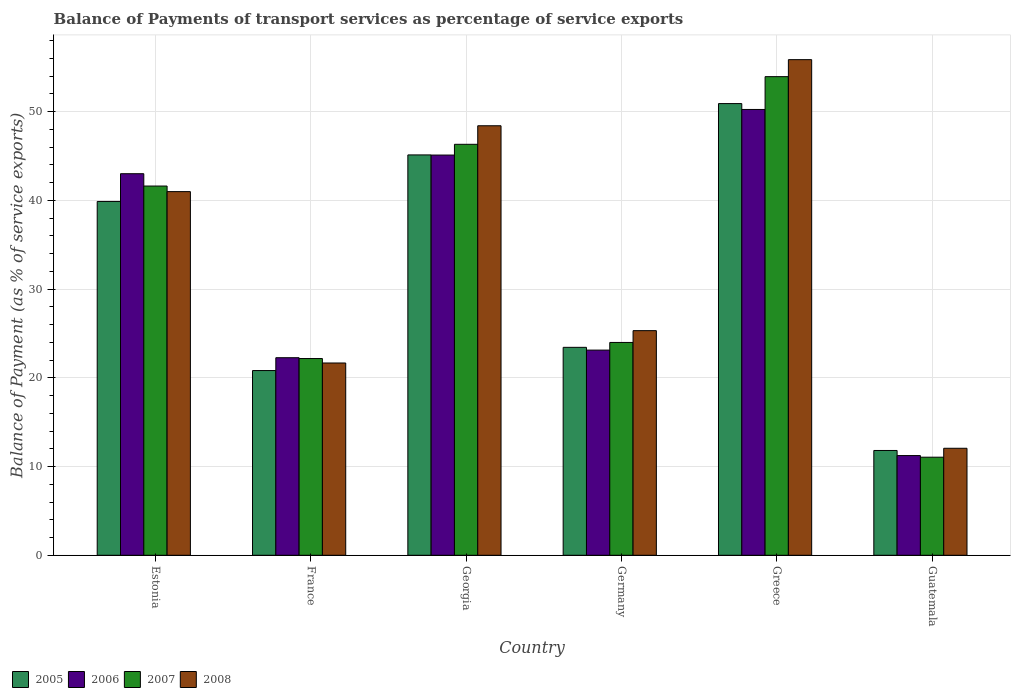How many different coloured bars are there?
Your answer should be very brief. 4. How many bars are there on the 1st tick from the right?
Make the answer very short. 4. What is the label of the 2nd group of bars from the left?
Offer a terse response. France. What is the balance of payments of transport services in 2007 in Greece?
Keep it short and to the point. 53.95. Across all countries, what is the maximum balance of payments of transport services in 2007?
Your answer should be very brief. 53.95. Across all countries, what is the minimum balance of payments of transport services in 2008?
Offer a very short reply. 12.06. In which country was the balance of payments of transport services in 2007 minimum?
Ensure brevity in your answer.  Guatemala. What is the total balance of payments of transport services in 2006 in the graph?
Your answer should be very brief. 195.02. What is the difference between the balance of payments of transport services in 2006 in Estonia and that in Greece?
Make the answer very short. -7.24. What is the difference between the balance of payments of transport services in 2008 in Estonia and the balance of payments of transport services in 2005 in Guatemala?
Keep it short and to the point. 29.18. What is the average balance of payments of transport services in 2008 per country?
Make the answer very short. 34.06. What is the difference between the balance of payments of transport services of/in 2006 and balance of payments of transport services of/in 2005 in Germany?
Ensure brevity in your answer.  -0.31. What is the ratio of the balance of payments of transport services in 2006 in Greece to that in Guatemala?
Offer a very short reply. 4.47. What is the difference between the highest and the second highest balance of payments of transport services in 2008?
Provide a short and direct response. 7.42. What is the difference between the highest and the lowest balance of payments of transport services in 2007?
Offer a very short reply. 42.9. Is the sum of the balance of payments of transport services in 2005 in Estonia and Greece greater than the maximum balance of payments of transport services in 2008 across all countries?
Keep it short and to the point. Yes. What does the 2nd bar from the right in France represents?
Make the answer very short. 2007. How many countries are there in the graph?
Your answer should be very brief. 6. How many legend labels are there?
Give a very brief answer. 4. What is the title of the graph?
Provide a short and direct response. Balance of Payments of transport services as percentage of service exports. Does "1979" appear as one of the legend labels in the graph?
Keep it short and to the point. No. What is the label or title of the Y-axis?
Give a very brief answer. Balance of Payment (as % of service exports). What is the Balance of Payment (as % of service exports) of 2005 in Estonia?
Provide a short and direct response. 39.88. What is the Balance of Payment (as % of service exports) in 2006 in Estonia?
Your answer should be compact. 43.01. What is the Balance of Payment (as % of service exports) of 2007 in Estonia?
Ensure brevity in your answer.  41.62. What is the Balance of Payment (as % of service exports) in 2008 in Estonia?
Make the answer very short. 40.99. What is the Balance of Payment (as % of service exports) of 2005 in France?
Your answer should be very brief. 20.82. What is the Balance of Payment (as % of service exports) of 2006 in France?
Offer a terse response. 22.27. What is the Balance of Payment (as % of service exports) in 2007 in France?
Provide a succinct answer. 22.18. What is the Balance of Payment (as % of service exports) of 2008 in France?
Provide a short and direct response. 21.67. What is the Balance of Payment (as % of service exports) of 2005 in Georgia?
Your response must be concise. 45.13. What is the Balance of Payment (as % of service exports) of 2006 in Georgia?
Your answer should be compact. 45.11. What is the Balance of Payment (as % of service exports) in 2007 in Georgia?
Provide a short and direct response. 46.33. What is the Balance of Payment (as % of service exports) of 2008 in Georgia?
Your answer should be compact. 48.42. What is the Balance of Payment (as % of service exports) in 2005 in Germany?
Offer a very short reply. 23.44. What is the Balance of Payment (as % of service exports) in 2006 in Germany?
Ensure brevity in your answer.  23.13. What is the Balance of Payment (as % of service exports) in 2007 in Germany?
Provide a succinct answer. 23.99. What is the Balance of Payment (as % of service exports) in 2008 in Germany?
Provide a succinct answer. 25.32. What is the Balance of Payment (as % of service exports) in 2005 in Greece?
Provide a short and direct response. 50.92. What is the Balance of Payment (as % of service exports) of 2006 in Greece?
Offer a terse response. 50.25. What is the Balance of Payment (as % of service exports) in 2007 in Greece?
Your answer should be compact. 53.95. What is the Balance of Payment (as % of service exports) in 2008 in Greece?
Provide a short and direct response. 55.87. What is the Balance of Payment (as % of service exports) in 2005 in Guatemala?
Offer a terse response. 11.81. What is the Balance of Payment (as % of service exports) of 2006 in Guatemala?
Provide a succinct answer. 11.24. What is the Balance of Payment (as % of service exports) in 2007 in Guatemala?
Keep it short and to the point. 11.06. What is the Balance of Payment (as % of service exports) of 2008 in Guatemala?
Offer a terse response. 12.06. Across all countries, what is the maximum Balance of Payment (as % of service exports) of 2005?
Your answer should be compact. 50.92. Across all countries, what is the maximum Balance of Payment (as % of service exports) in 2006?
Offer a terse response. 50.25. Across all countries, what is the maximum Balance of Payment (as % of service exports) of 2007?
Provide a succinct answer. 53.95. Across all countries, what is the maximum Balance of Payment (as % of service exports) of 2008?
Provide a succinct answer. 55.87. Across all countries, what is the minimum Balance of Payment (as % of service exports) of 2005?
Your response must be concise. 11.81. Across all countries, what is the minimum Balance of Payment (as % of service exports) of 2006?
Keep it short and to the point. 11.24. Across all countries, what is the minimum Balance of Payment (as % of service exports) of 2007?
Your answer should be compact. 11.06. Across all countries, what is the minimum Balance of Payment (as % of service exports) in 2008?
Ensure brevity in your answer.  12.06. What is the total Balance of Payment (as % of service exports) of 2005 in the graph?
Offer a very short reply. 192.01. What is the total Balance of Payment (as % of service exports) in 2006 in the graph?
Provide a short and direct response. 195.02. What is the total Balance of Payment (as % of service exports) of 2007 in the graph?
Your response must be concise. 199.12. What is the total Balance of Payment (as % of service exports) of 2008 in the graph?
Make the answer very short. 204.34. What is the difference between the Balance of Payment (as % of service exports) of 2005 in Estonia and that in France?
Make the answer very short. 19.06. What is the difference between the Balance of Payment (as % of service exports) in 2006 in Estonia and that in France?
Ensure brevity in your answer.  20.74. What is the difference between the Balance of Payment (as % of service exports) in 2007 in Estonia and that in France?
Offer a very short reply. 19.45. What is the difference between the Balance of Payment (as % of service exports) in 2008 in Estonia and that in France?
Provide a succinct answer. 19.32. What is the difference between the Balance of Payment (as % of service exports) in 2005 in Estonia and that in Georgia?
Ensure brevity in your answer.  -5.25. What is the difference between the Balance of Payment (as % of service exports) in 2006 in Estonia and that in Georgia?
Make the answer very short. -2.1. What is the difference between the Balance of Payment (as % of service exports) in 2007 in Estonia and that in Georgia?
Give a very brief answer. -4.7. What is the difference between the Balance of Payment (as % of service exports) of 2008 in Estonia and that in Georgia?
Your answer should be very brief. -7.42. What is the difference between the Balance of Payment (as % of service exports) in 2005 in Estonia and that in Germany?
Give a very brief answer. 16.44. What is the difference between the Balance of Payment (as % of service exports) of 2006 in Estonia and that in Germany?
Provide a succinct answer. 19.89. What is the difference between the Balance of Payment (as % of service exports) of 2007 in Estonia and that in Germany?
Ensure brevity in your answer.  17.63. What is the difference between the Balance of Payment (as % of service exports) in 2008 in Estonia and that in Germany?
Make the answer very short. 15.67. What is the difference between the Balance of Payment (as % of service exports) of 2005 in Estonia and that in Greece?
Provide a short and direct response. -11.03. What is the difference between the Balance of Payment (as % of service exports) in 2006 in Estonia and that in Greece?
Ensure brevity in your answer.  -7.24. What is the difference between the Balance of Payment (as % of service exports) in 2007 in Estonia and that in Greece?
Offer a very short reply. -12.33. What is the difference between the Balance of Payment (as % of service exports) in 2008 in Estonia and that in Greece?
Your answer should be compact. -14.87. What is the difference between the Balance of Payment (as % of service exports) in 2005 in Estonia and that in Guatemala?
Make the answer very short. 28.07. What is the difference between the Balance of Payment (as % of service exports) in 2006 in Estonia and that in Guatemala?
Your answer should be compact. 31.77. What is the difference between the Balance of Payment (as % of service exports) in 2007 in Estonia and that in Guatemala?
Offer a very short reply. 30.57. What is the difference between the Balance of Payment (as % of service exports) of 2008 in Estonia and that in Guatemala?
Make the answer very short. 28.93. What is the difference between the Balance of Payment (as % of service exports) of 2005 in France and that in Georgia?
Provide a short and direct response. -24.31. What is the difference between the Balance of Payment (as % of service exports) in 2006 in France and that in Georgia?
Your response must be concise. -22.84. What is the difference between the Balance of Payment (as % of service exports) in 2007 in France and that in Georgia?
Keep it short and to the point. -24.15. What is the difference between the Balance of Payment (as % of service exports) of 2008 in France and that in Georgia?
Ensure brevity in your answer.  -26.74. What is the difference between the Balance of Payment (as % of service exports) in 2005 in France and that in Germany?
Your response must be concise. -2.62. What is the difference between the Balance of Payment (as % of service exports) in 2006 in France and that in Germany?
Give a very brief answer. -0.86. What is the difference between the Balance of Payment (as % of service exports) of 2007 in France and that in Germany?
Provide a succinct answer. -1.81. What is the difference between the Balance of Payment (as % of service exports) in 2008 in France and that in Germany?
Your answer should be compact. -3.65. What is the difference between the Balance of Payment (as % of service exports) of 2005 in France and that in Greece?
Provide a succinct answer. -30.09. What is the difference between the Balance of Payment (as % of service exports) of 2006 in France and that in Greece?
Keep it short and to the point. -27.98. What is the difference between the Balance of Payment (as % of service exports) of 2007 in France and that in Greece?
Offer a very short reply. -31.78. What is the difference between the Balance of Payment (as % of service exports) of 2008 in France and that in Greece?
Make the answer very short. -34.19. What is the difference between the Balance of Payment (as % of service exports) in 2005 in France and that in Guatemala?
Ensure brevity in your answer.  9.01. What is the difference between the Balance of Payment (as % of service exports) of 2006 in France and that in Guatemala?
Offer a terse response. 11.03. What is the difference between the Balance of Payment (as % of service exports) of 2007 in France and that in Guatemala?
Your response must be concise. 11.12. What is the difference between the Balance of Payment (as % of service exports) in 2008 in France and that in Guatemala?
Keep it short and to the point. 9.61. What is the difference between the Balance of Payment (as % of service exports) in 2005 in Georgia and that in Germany?
Ensure brevity in your answer.  21.69. What is the difference between the Balance of Payment (as % of service exports) in 2006 in Georgia and that in Germany?
Your response must be concise. 21.99. What is the difference between the Balance of Payment (as % of service exports) of 2007 in Georgia and that in Germany?
Provide a succinct answer. 22.34. What is the difference between the Balance of Payment (as % of service exports) of 2008 in Georgia and that in Germany?
Offer a terse response. 23.1. What is the difference between the Balance of Payment (as % of service exports) in 2005 in Georgia and that in Greece?
Offer a terse response. -5.78. What is the difference between the Balance of Payment (as % of service exports) in 2006 in Georgia and that in Greece?
Ensure brevity in your answer.  -5.14. What is the difference between the Balance of Payment (as % of service exports) in 2007 in Georgia and that in Greece?
Provide a short and direct response. -7.63. What is the difference between the Balance of Payment (as % of service exports) in 2008 in Georgia and that in Greece?
Your answer should be very brief. -7.45. What is the difference between the Balance of Payment (as % of service exports) of 2005 in Georgia and that in Guatemala?
Your answer should be compact. 33.32. What is the difference between the Balance of Payment (as % of service exports) of 2006 in Georgia and that in Guatemala?
Offer a terse response. 33.88. What is the difference between the Balance of Payment (as % of service exports) in 2007 in Georgia and that in Guatemala?
Provide a succinct answer. 35.27. What is the difference between the Balance of Payment (as % of service exports) of 2008 in Georgia and that in Guatemala?
Keep it short and to the point. 36.35. What is the difference between the Balance of Payment (as % of service exports) of 2005 in Germany and that in Greece?
Provide a succinct answer. -27.48. What is the difference between the Balance of Payment (as % of service exports) of 2006 in Germany and that in Greece?
Offer a terse response. -27.13. What is the difference between the Balance of Payment (as % of service exports) in 2007 in Germany and that in Greece?
Make the answer very short. -29.96. What is the difference between the Balance of Payment (as % of service exports) of 2008 in Germany and that in Greece?
Keep it short and to the point. -30.55. What is the difference between the Balance of Payment (as % of service exports) of 2005 in Germany and that in Guatemala?
Provide a succinct answer. 11.63. What is the difference between the Balance of Payment (as % of service exports) in 2006 in Germany and that in Guatemala?
Provide a succinct answer. 11.89. What is the difference between the Balance of Payment (as % of service exports) of 2007 in Germany and that in Guatemala?
Offer a very short reply. 12.93. What is the difference between the Balance of Payment (as % of service exports) of 2008 in Germany and that in Guatemala?
Make the answer very short. 13.26. What is the difference between the Balance of Payment (as % of service exports) in 2005 in Greece and that in Guatemala?
Offer a terse response. 39.1. What is the difference between the Balance of Payment (as % of service exports) of 2006 in Greece and that in Guatemala?
Your response must be concise. 39.02. What is the difference between the Balance of Payment (as % of service exports) of 2007 in Greece and that in Guatemala?
Keep it short and to the point. 42.9. What is the difference between the Balance of Payment (as % of service exports) of 2008 in Greece and that in Guatemala?
Keep it short and to the point. 43.81. What is the difference between the Balance of Payment (as % of service exports) in 2005 in Estonia and the Balance of Payment (as % of service exports) in 2006 in France?
Your answer should be very brief. 17.61. What is the difference between the Balance of Payment (as % of service exports) in 2005 in Estonia and the Balance of Payment (as % of service exports) in 2007 in France?
Provide a succinct answer. 17.71. What is the difference between the Balance of Payment (as % of service exports) of 2005 in Estonia and the Balance of Payment (as % of service exports) of 2008 in France?
Ensure brevity in your answer.  18.21. What is the difference between the Balance of Payment (as % of service exports) in 2006 in Estonia and the Balance of Payment (as % of service exports) in 2007 in France?
Offer a very short reply. 20.84. What is the difference between the Balance of Payment (as % of service exports) of 2006 in Estonia and the Balance of Payment (as % of service exports) of 2008 in France?
Offer a terse response. 21.34. What is the difference between the Balance of Payment (as % of service exports) in 2007 in Estonia and the Balance of Payment (as % of service exports) in 2008 in France?
Your response must be concise. 19.95. What is the difference between the Balance of Payment (as % of service exports) of 2005 in Estonia and the Balance of Payment (as % of service exports) of 2006 in Georgia?
Provide a succinct answer. -5.23. What is the difference between the Balance of Payment (as % of service exports) of 2005 in Estonia and the Balance of Payment (as % of service exports) of 2007 in Georgia?
Offer a very short reply. -6.44. What is the difference between the Balance of Payment (as % of service exports) in 2005 in Estonia and the Balance of Payment (as % of service exports) in 2008 in Georgia?
Your response must be concise. -8.53. What is the difference between the Balance of Payment (as % of service exports) in 2006 in Estonia and the Balance of Payment (as % of service exports) in 2007 in Georgia?
Offer a very short reply. -3.31. What is the difference between the Balance of Payment (as % of service exports) in 2006 in Estonia and the Balance of Payment (as % of service exports) in 2008 in Georgia?
Your answer should be compact. -5.4. What is the difference between the Balance of Payment (as % of service exports) in 2007 in Estonia and the Balance of Payment (as % of service exports) in 2008 in Georgia?
Ensure brevity in your answer.  -6.8. What is the difference between the Balance of Payment (as % of service exports) in 2005 in Estonia and the Balance of Payment (as % of service exports) in 2006 in Germany?
Offer a terse response. 16.76. What is the difference between the Balance of Payment (as % of service exports) in 2005 in Estonia and the Balance of Payment (as % of service exports) in 2007 in Germany?
Give a very brief answer. 15.89. What is the difference between the Balance of Payment (as % of service exports) in 2005 in Estonia and the Balance of Payment (as % of service exports) in 2008 in Germany?
Your answer should be very brief. 14.56. What is the difference between the Balance of Payment (as % of service exports) in 2006 in Estonia and the Balance of Payment (as % of service exports) in 2007 in Germany?
Give a very brief answer. 19.02. What is the difference between the Balance of Payment (as % of service exports) of 2006 in Estonia and the Balance of Payment (as % of service exports) of 2008 in Germany?
Offer a terse response. 17.69. What is the difference between the Balance of Payment (as % of service exports) in 2007 in Estonia and the Balance of Payment (as % of service exports) in 2008 in Germany?
Ensure brevity in your answer.  16.3. What is the difference between the Balance of Payment (as % of service exports) of 2005 in Estonia and the Balance of Payment (as % of service exports) of 2006 in Greece?
Keep it short and to the point. -10.37. What is the difference between the Balance of Payment (as % of service exports) in 2005 in Estonia and the Balance of Payment (as % of service exports) in 2007 in Greece?
Your response must be concise. -14.07. What is the difference between the Balance of Payment (as % of service exports) of 2005 in Estonia and the Balance of Payment (as % of service exports) of 2008 in Greece?
Ensure brevity in your answer.  -15.98. What is the difference between the Balance of Payment (as % of service exports) of 2006 in Estonia and the Balance of Payment (as % of service exports) of 2007 in Greece?
Make the answer very short. -10.94. What is the difference between the Balance of Payment (as % of service exports) of 2006 in Estonia and the Balance of Payment (as % of service exports) of 2008 in Greece?
Ensure brevity in your answer.  -12.86. What is the difference between the Balance of Payment (as % of service exports) of 2007 in Estonia and the Balance of Payment (as % of service exports) of 2008 in Greece?
Offer a very short reply. -14.25. What is the difference between the Balance of Payment (as % of service exports) in 2005 in Estonia and the Balance of Payment (as % of service exports) in 2006 in Guatemala?
Give a very brief answer. 28.65. What is the difference between the Balance of Payment (as % of service exports) in 2005 in Estonia and the Balance of Payment (as % of service exports) in 2007 in Guatemala?
Your answer should be very brief. 28.83. What is the difference between the Balance of Payment (as % of service exports) of 2005 in Estonia and the Balance of Payment (as % of service exports) of 2008 in Guatemala?
Your answer should be very brief. 27.82. What is the difference between the Balance of Payment (as % of service exports) in 2006 in Estonia and the Balance of Payment (as % of service exports) in 2007 in Guatemala?
Provide a succinct answer. 31.96. What is the difference between the Balance of Payment (as % of service exports) in 2006 in Estonia and the Balance of Payment (as % of service exports) in 2008 in Guatemala?
Provide a succinct answer. 30.95. What is the difference between the Balance of Payment (as % of service exports) in 2007 in Estonia and the Balance of Payment (as % of service exports) in 2008 in Guatemala?
Provide a succinct answer. 29.56. What is the difference between the Balance of Payment (as % of service exports) in 2005 in France and the Balance of Payment (as % of service exports) in 2006 in Georgia?
Offer a very short reply. -24.29. What is the difference between the Balance of Payment (as % of service exports) of 2005 in France and the Balance of Payment (as % of service exports) of 2007 in Georgia?
Give a very brief answer. -25.5. What is the difference between the Balance of Payment (as % of service exports) of 2005 in France and the Balance of Payment (as % of service exports) of 2008 in Georgia?
Your answer should be very brief. -27.6. What is the difference between the Balance of Payment (as % of service exports) of 2006 in France and the Balance of Payment (as % of service exports) of 2007 in Georgia?
Offer a very short reply. -24.06. What is the difference between the Balance of Payment (as % of service exports) of 2006 in France and the Balance of Payment (as % of service exports) of 2008 in Georgia?
Ensure brevity in your answer.  -26.15. What is the difference between the Balance of Payment (as % of service exports) in 2007 in France and the Balance of Payment (as % of service exports) in 2008 in Georgia?
Keep it short and to the point. -26.24. What is the difference between the Balance of Payment (as % of service exports) of 2005 in France and the Balance of Payment (as % of service exports) of 2006 in Germany?
Your response must be concise. -2.31. What is the difference between the Balance of Payment (as % of service exports) of 2005 in France and the Balance of Payment (as % of service exports) of 2007 in Germany?
Make the answer very short. -3.17. What is the difference between the Balance of Payment (as % of service exports) of 2005 in France and the Balance of Payment (as % of service exports) of 2008 in Germany?
Ensure brevity in your answer.  -4.5. What is the difference between the Balance of Payment (as % of service exports) of 2006 in France and the Balance of Payment (as % of service exports) of 2007 in Germany?
Provide a succinct answer. -1.72. What is the difference between the Balance of Payment (as % of service exports) in 2006 in France and the Balance of Payment (as % of service exports) in 2008 in Germany?
Offer a terse response. -3.05. What is the difference between the Balance of Payment (as % of service exports) in 2007 in France and the Balance of Payment (as % of service exports) in 2008 in Germany?
Provide a succinct answer. -3.14. What is the difference between the Balance of Payment (as % of service exports) in 2005 in France and the Balance of Payment (as % of service exports) in 2006 in Greece?
Give a very brief answer. -29.43. What is the difference between the Balance of Payment (as % of service exports) in 2005 in France and the Balance of Payment (as % of service exports) in 2007 in Greece?
Your answer should be compact. -33.13. What is the difference between the Balance of Payment (as % of service exports) of 2005 in France and the Balance of Payment (as % of service exports) of 2008 in Greece?
Provide a succinct answer. -35.05. What is the difference between the Balance of Payment (as % of service exports) of 2006 in France and the Balance of Payment (as % of service exports) of 2007 in Greece?
Provide a succinct answer. -31.68. What is the difference between the Balance of Payment (as % of service exports) of 2006 in France and the Balance of Payment (as % of service exports) of 2008 in Greece?
Your answer should be compact. -33.6. What is the difference between the Balance of Payment (as % of service exports) in 2007 in France and the Balance of Payment (as % of service exports) in 2008 in Greece?
Give a very brief answer. -33.69. What is the difference between the Balance of Payment (as % of service exports) in 2005 in France and the Balance of Payment (as % of service exports) in 2006 in Guatemala?
Offer a very short reply. 9.58. What is the difference between the Balance of Payment (as % of service exports) of 2005 in France and the Balance of Payment (as % of service exports) of 2007 in Guatemala?
Give a very brief answer. 9.77. What is the difference between the Balance of Payment (as % of service exports) of 2005 in France and the Balance of Payment (as % of service exports) of 2008 in Guatemala?
Offer a terse response. 8.76. What is the difference between the Balance of Payment (as % of service exports) in 2006 in France and the Balance of Payment (as % of service exports) in 2007 in Guatemala?
Ensure brevity in your answer.  11.21. What is the difference between the Balance of Payment (as % of service exports) of 2006 in France and the Balance of Payment (as % of service exports) of 2008 in Guatemala?
Give a very brief answer. 10.21. What is the difference between the Balance of Payment (as % of service exports) of 2007 in France and the Balance of Payment (as % of service exports) of 2008 in Guatemala?
Your response must be concise. 10.11. What is the difference between the Balance of Payment (as % of service exports) in 2005 in Georgia and the Balance of Payment (as % of service exports) in 2006 in Germany?
Give a very brief answer. 22. What is the difference between the Balance of Payment (as % of service exports) in 2005 in Georgia and the Balance of Payment (as % of service exports) in 2007 in Germany?
Make the answer very short. 21.14. What is the difference between the Balance of Payment (as % of service exports) in 2005 in Georgia and the Balance of Payment (as % of service exports) in 2008 in Germany?
Make the answer very short. 19.81. What is the difference between the Balance of Payment (as % of service exports) of 2006 in Georgia and the Balance of Payment (as % of service exports) of 2007 in Germany?
Your answer should be compact. 21.12. What is the difference between the Balance of Payment (as % of service exports) of 2006 in Georgia and the Balance of Payment (as % of service exports) of 2008 in Germany?
Offer a terse response. 19.79. What is the difference between the Balance of Payment (as % of service exports) in 2007 in Georgia and the Balance of Payment (as % of service exports) in 2008 in Germany?
Your response must be concise. 21.01. What is the difference between the Balance of Payment (as % of service exports) in 2005 in Georgia and the Balance of Payment (as % of service exports) in 2006 in Greece?
Keep it short and to the point. -5.12. What is the difference between the Balance of Payment (as % of service exports) in 2005 in Georgia and the Balance of Payment (as % of service exports) in 2007 in Greece?
Make the answer very short. -8.82. What is the difference between the Balance of Payment (as % of service exports) of 2005 in Georgia and the Balance of Payment (as % of service exports) of 2008 in Greece?
Provide a succinct answer. -10.74. What is the difference between the Balance of Payment (as % of service exports) in 2006 in Georgia and the Balance of Payment (as % of service exports) in 2007 in Greece?
Provide a short and direct response. -8.84. What is the difference between the Balance of Payment (as % of service exports) in 2006 in Georgia and the Balance of Payment (as % of service exports) in 2008 in Greece?
Ensure brevity in your answer.  -10.75. What is the difference between the Balance of Payment (as % of service exports) in 2007 in Georgia and the Balance of Payment (as % of service exports) in 2008 in Greece?
Your response must be concise. -9.54. What is the difference between the Balance of Payment (as % of service exports) in 2005 in Georgia and the Balance of Payment (as % of service exports) in 2006 in Guatemala?
Provide a succinct answer. 33.89. What is the difference between the Balance of Payment (as % of service exports) in 2005 in Georgia and the Balance of Payment (as % of service exports) in 2007 in Guatemala?
Your answer should be very brief. 34.07. What is the difference between the Balance of Payment (as % of service exports) of 2005 in Georgia and the Balance of Payment (as % of service exports) of 2008 in Guatemala?
Offer a terse response. 33.07. What is the difference between the Balance of Payment (as % of service exports) in 2006 in Georgia and the Balance of Payment (as % of service exports) in 2007 in Guatemala?
Provide a short and direct response. 34.06. What is the difference between the Balance of Payment (as % of service exports) in 2006 in Georgia and the Balance of Payment (as % of service exports) in 2008 in Guatemala?
Make the answer very short. 33.05. What is the difference between the Balance of Payment (as % of service exports) of 2007 in Georgia and the Balance of Payment (as % of service exports) of 2008 in Guatemala?
Ensure brevity in your answer.  34.26. What is the difference between the Balance of Payment (as % of service exports) of 2005 in Germany and the Balance of Payment (as % of service exports) of 2006 in Greece?
Ensure brevity in your answer.  -26.81. What is the difference between the Balance of Payment (as % of service exports) of 2005 in Germany and the Balance of Payment (as % of service exports) of 2007 in Greece?
Keep it short and to the point. -30.51. What is the difference between the Balance of Payment (as % of service exports) of 2005 in Germany and the Balance of Payment (as % of service exports) of 2008 in Greece?
Provide a succinct answer. -32.43. What is the difference between the Balance of Payment (as % of service exports) in 2006 in Germany and the Balance of Payment (as % of service exports) in 2007 in Greece?
Keep it short and to the point. -30.83. What is the difference between the Balance of Payment (as % of service exports) in 2006 in Germany and the Balance of Payment (as % of service exports) in 2008 in Greece?
Give a very brief answer. -32.74. What is the difference between the Balance of Payment (as % of service exports) of 2007 in Germany and the Balance of Payment (as % of service exports) of 2008 in Greece?
Give a very brief answer. -31.88. What is the difference between the Balance of Payment (as % of service exports) of 2005 in Germany and the Balance of Payment (as % of service exports) of 2006 in Guatemala?
Ensure brevity in your answer.  12.2. What is the difference between the Balance of Payment (as % of service exports) of 2005 in Germany and the Balance of Payment (as % of service exports) of 2007 in Guatemala?
Make the answer very short. 12.38. What is the difference between the Balance of Payment (as % of service exports) of 2005 in Germany and the Balance of Payment (as % of service exports) of 2008 in Guatemala?
Offer a very short reply. 11.38. What is the difference between the Balance of Payment (as % of service exports) of 2006 in Germany and the Balance of Payment (as % of service exports) of 2007 in Guatemala?
Your answer should be compact. 12.07. What is the difference between the Balance of Payment (as % of service exports) of 2006 in Germany and the Balance of Payment (as % of service exports) of 2008 in Guatemala?
Provide a succinct answer. 11.06. What is the difference between the Balance of Payment (as % of service exports) in 2007 in Germany and the Balance of Payment (as % of service exports) in 2008 in Guatemala?
Your answer should be compact. 11.93. What is the difference between the Balance of Payment (as % of service exports) in 2005 in Greece and the Balance of Payment (as % of service exports) in 2006 in Guatemala?
Offer a terse response. 39.68. What is the difference between the Balance of Payment (as % of service exports) of 2005 in Greece and the Balance of Payment (as % of service exports) of 2007 in Guatemala?
Your answer should be very brief. 39.86. What is the difference between the Balance of Payment (as % of service exports) of 2005 in Greece and the Balance of Payment (as % of service exports) of 2008 in Guatemala?
Your answer should be very brief. 38.85. What is the difference between the Balance of Payment (as % of service exports) of 2006 in Greece and the Balance of Payment (as % of service exports) of 2007 in Guatemala?
Your response must be concise. 39.2. What is the difference between the Balance of Payment (as % of service exports) in 2006 in Greece and the Balance of Payment (as % of service exports) in 2008 in Guatemala?
Offer a very short reply. 38.19. What is the difference between the Balance of Payment (as % of service exports) of 2007 in Greece and the Balance of Payment (as % of service exports) of 2008 in Guatemala?
Provide a short and direct response. 41.89. What is the average Balance of Payment (as % of service exports) in 2005 per country?
Your answer should be very brief. 32. What is the average Balance of Payment (as % of service exports) of 2006 per country?
Your answer should be compact. 32.5. What is the average Balance of Payment (as % of service exports) in 2007 per country?
Your answer should be compact. 33.19. What is the average Balance of Payment (as % of service exports) of 2008 per country?
Your response must be concise. 34.06. What is the difference between the Balance of Payment (as % of service exports) of 2005 and Balance of Payment (as % of service exports) of 2006 in Estonia?
Provide a succinct answer. -3.13. What is the difference between the Balance of Payment (as % of service exports) of 2005 and Balance of Payment (as % of service exports) of 2007 in Estonia?
Keep it short and to the point. -1.74. What is the difference between the Balance of Payment (as % of service exports) of 2005 and Balance of Payment (as % of service exports) of 2008 in Estonia?
Offer a terse response. -1.11. What is the difference between the Balance of Payment (as % of service exports) of 2006 and Balance of Payment (as % of service exports) of 2007 in Estonia?
Provide a succinct answer. 1.39. What is the difference between the Balance of Payment (as % of service exports) of 2006 and Balance of Payment (as % of service exports) of 2008 in Estonia?
Your answer should be compact. 2.02. What is the difference between the Balance of Payment (as % of service exports) of 2007 and Balance of Payment (as % of service exports) of 2008 in Estonia?
Your response must be concise. 0.63. What is the difference between the Balance of Payment (as % of service exports) in 2005 and Balance of Payment (as % of service exports) in 2006 in France?
Provide a succinct answer. -1.45. What is the difference between the Balance of Payment (as % of service exports) of 2005 and Balance of Payment (as % of service exports) of 2007 in France?
Keep it short and to the point. -1.35. What is the difference between the Balance of Payment (as % of service exports) of 2005 and Balance of Payment (as % of service exports) of 2008 in France?
Offer a terse response. -0.85. What is the difference between the Balance of Payment (as % of service exports) of 2006 and Balance of Payment (as % of service exports) of 2007 in France?
Offer a very short reply. 0.09. What is the difference between the Balance of Payment (as % of service exports) of 2006 and Balance of Payment (as % of service exports) of 2008 in France?
Your answer should be compact. 0.6. What is the difference between the Balance of Payment (as % of service exports) in 2007 and Balance of Payment (as % of service exports) in 2008 in France?
Your response must be concise. 0.5. What is the difference between the Balance of Payment (as % of service exports) of 2005 and Balance of Payment (as % of service exports) of 2006 in Georgia?
Your response must be concise. 0.02. What is the difference between the Balance of Payment (as % of service exports) of 2005 and Balance of Payment (as % of service exports) of 2007 in Georgia?
Keep it short and to the point. -1.2. What is the difference between the Balance of Payment (as % of service exports) in 2005 and Balance of Payment (as % of service exports) in 2008 in Georgia?
Your answer should be compact. -3.29. What is the difference between the Balance of Payment (as % of service exports) of 2006 and Balance of Payment (as % of service exports) of 2007 in Georgia?
Your answer should be compact. -1.21. What is the difference between the Balance of Payment (as % of service exports) of 2006 and Balance of Payment (as % of service exports) of 2008 in Georgia?
Your answer should be very brief. -3.3. What is the difference between the Balance of Payment (as % of service exports) of 2007 and Balance of Payment (as % of service exports) of 2008 in Georgia?
Provide a short and direct response. -2.09. What is the difference between the Balance of Payment (as % of service exports) in 2005 and Balance of Payment (as % of service exports) in 2006 in Germany?
Make the answer very short. 0.31. What is the difference between the Balance of Payment (as % of service exports) of 2005 and Balance of Payment (as % of service exports) of 2007 in Germany?
Provide a succinct answer. -0.55. What is the difference between the Balance of Payment (as % of service exports) of 2005 and Balance of Payment (as % of service exports) of 2008 in Germany?
Offer a very short reply. -1.88. What is the difference between the Balance of Payment (as % of service exports) in 2006 and Balance of Payment (as % of service exports) in 2007 in Germany?
Provide a short and direct response. -0.86. What is the difference between the Balance of Payment (as % of service exports) of 2006 and Balance of Payment (as % of service exports) of 2008 in Germany?
Provide a short and direct response. -2.19. What is the difference between the Balance of Payment (as % of service exports) of 2007 and Balance of Payment (as % of service exports) of 2008 in Germany?
Provide a short and direct response. -1.33. What is the difference between the Balance of Payment (as % of service exports) in 2005 and Balance of Payment (as % of service exports) in 2006 in Greece?
Offer a terse response. 0.66. What is the difference between the Balance of Payment (as % of service exports) in 2005 and Balance of Payment (as % of service exports) in 2007 in Greece?
Ensure brevity in your answer.  -3.04. What is the difference between the Balance of Payment (as % of service exports) in 2005 and Balance of Payment (as % of service exports) in 2008 in Greece?
Provide a succinct answer. -4.95. What is the difference between the Balance of Payment (as % of service exports) in 2006 and Balance of Payment (as % of service exports) in 2007 in Greece?
Provide a succinct answer. -3.7. What is the difference between the Balance of Payment (as % of service exports) in 2006 and Balance of Payment (as % of service exports) in 2008 in Greece?
Make the answer very short. -5.61. What is the difference between the Balance of Payment (as % of service exports) of 2007 and Balance of Payment (as % of service exports) of 2008 in Greece?
Provide a succinct answer. -1.92. What is the difference between the Balance of Payment (as % of service exports) in 2005 and Balance of Payment (as % of service exports) in 2006 in Guatemala?
Provide a succinct answer. 0.58. What is the difference between the Balance of Payment (as % of service exports) of 2005 and Balance of Payment (as % of service exports) of 2007 in Guatemala?
Provide a succinct answer. 0.76. What is the difference between the Balance of Payment (as % of service exports) of 2005 and Balance of Payment (as % of service exports) of 2008 in Guatemala?
Your response must be concise. -0.25. What is the difference between the Balance of Payment (as % of service exports) of 2006 and Balance of Payment (as % of service exports) of 2007 in Guatemala?
Ensure brevity in your answer.  0.18. What is the difference between the Balance of Payment (as % of service exports) in 2006 and Balance of Payment (as % of service exports) in 2008 in Guatemala?
Provide a short and direct response. -0.82. What is the difference between the Balance of Payment (as % of service exports) in 2007 and Balance of Payment (as % of service exports) in 2008 in Guatemala?
Provide a short and direct response. -1.01. What is the ratio of the Balance of Payment (as % of service exports) of 2005 in Estonia to that in France?
Your response must be concise. 1.92. What is the ratio of the Balance of Payment (as % of service exports) of 2006 in Estonia to that in France?
Give a very brief answer. 1.93. What is the ratio of the Balance of Payment (as % of service exports) in 2007 in Estonia to that in France?
Your answer should be compact. 1.88. What is the ratio of the Balance of Payment (as % of service exports) in 2008 in Estonia to that in France?
Offer a very short reply. 1.89. What is the ratio of the Balance of Payment (as % of service exports) of 2005 in Estonia to that in Georgia?
Ensure brevity in your answer.  0.88. What is the ratio of the Balance of Payment (as % of service exports) in 2006 in Estonia to that in Georgia?
Offer a terse response. 0.95. What is the ratio of the Balance of Payment (as % of service exports) of 2007 in Estonia to that in Georgia?
Your answer should be compact. 0.9. What is the ratio of the Balance of Payment (as % of service exports) of 2008 in Estonia to that in Georgia?
Make the answer very short. 0.85. What is the ratio of the Balance of Payment (as % of service exports) in 2005 in Estonia to that in Germany?
Offer a very short reply. 1.7. What is the ratio of the Balance of Payment (as % of service exports) of 2006 in Estonia to that in Germany?
Ensure brevity in your answer.  1.86. What is the ratio of the Balance of Payment (as % of service exports) of 2007 in Estonia to that in Germany?
Your answer should be compact. 1.73. What is the ratio of the Balance of Payment (as % of service exports) of 2008 in Estonia to that in Germany?
Ensure brevity in your answer.  1.62. What is the ratio of the Balance of Payment (as % of service exports) of 2005 in Estonia to that in Greece?
Provide a short and direct response. 0.78. What is the ratio of the Balance of Payment (as % of service exports) in 2006 in Estonia to that in Greece?
Offer a terse response. 0.86. What is the ratio of the Balance of Payment (as % of service exports) in 2007 in Estonia to that in Greece?
Your response must be concise. 0.77. What is the ratio of the Balance of Payment (as % of service exports) of 2008 in Estonia to that in Greece?
Offer a very short reply. 0.73. What is the ratio of the Balance of Payment (as % of service exports) in 2005 in Estonia to that in Guatemala?
Offer a terse response. 3.38. What is the ratio of the Balance of Payment (as % of service exports) of 2006 in Estonia to that in Guatemala?
Offer a terse response. 3.83. What is the ratio of the Balance of Payment (as % of service exports) in 2007 in Estonia to that in Guatemala?
Your response must be concise. 3.76. What is the ratio of the Balance of Payment (as % of service exports) of 2008 in Estonia to that in Guatemala?
Offer a very short reply. 3.4. What is the ratio of the Balance of Payment (as % of service exports) of 2005 in France to that in Georgia?
Your response must be concise. 0.46. What is the ratio of the Balance of Payment (as % of service exports) in 2006 in France to that in Georgia?
Offer a terse response. 0.49. What is the ratio of the Balance of Payment (as % of service exports) in 2007 in France to that in Georgia?
Provide a succinct answer. 0.48. What is the ratio of the Balance of Payment (as % of service exports) of 2008 in France to that in Georgia?
Give a very brief answer. 0.45. What is the ratio of the Balance of Payment (as % of service exports) in 2005 in France to that in Germany?
Offer a terse response. 0.89. What is the ratio of the Balance of Payment (as % of service exports) in 2006 in France to that in Germany?
Ensure brevity in your answer.  0.96. What is the ratio of the Balance of Payment (as % of service exports) in 2007 in France to that in Germany?
Make the answer very short. 0.92. What is the ratio of the Balance of Payment (as % of service exports) in 2008 in France to that in Germany?
Ensure brevity in your answer.  0.86. What is the ratio of the Balance of Payment (as % of service exports) in 2005 in France to that in Greece?
Give a very brief answer. 0.41. What is the ratio of the Balance of Payment (as % of service exports) in 2006 in France to that in Greece?
Your answer should be very brief. 0.44. What is the ratio of the Balance of Payment (as % of service exports) of 2007 in France to that in Greece?
Your response must be concise. 0.41. What is the ratio of the Balance of Payment (as % of service exports) of 2008 in France to that in Greece?
Ensure brevity in your answer.  0.39. What is the ratio of the Balance of Payment (as % of service exports) in 2005 in France to that in Guatemala?
Ensure brevity in your answer.  1.76. What is the ratio of the Balance of Payment (as % of service exports) in 2006 in France to that in Guatemala?
Your answer should be very brief. 1.98. What is the ratio of the Balance of Payment (as % of service exports) in 2007 in France to that in Guatemala?
Ensure brevity in your answer.  2.01. What is the ratio of the Balance of Payment (as % of service exports) in 2008 in France to that in Guatemala?
Give a very brief answer. 1.8. What is the ratio of the Balance of Payment (as % of service exports) in 2005 in Georgia to that in Germany?
Your answer should be very brief. 1.93. What is the ratio of the Balance of Payment (as % of service exports) in 2006 in Georgia to that in Germany?
Give a very brief answer. 1.95. What is the ratio of the Balance of Payment (as % of service exports) of 2007 in Georgia to that in Germany?
Ensure brevity in your answer.  1.93. What is the ratio of the Balance of Payment (as % of service exports) of 2008 in Georgia to that in Germany?
Offer a terse response. 1.91. What is the ratio of the Balance of Payment (as % of service exports) of 2005 in Georgia to that in Greece?
Your answer should be very brief. 0.89. What is the ratio of the Balance of Payment (as % of service exports) in 2006 in Georgia to that in Greece?
Provide a short and direct response. 0.9. What is the ratio of the Balance of Payment (as % of service exports) in 2007 in Georgia to that in Greece?
Provide a short and direct response. 0.86. What is the ratio of the Balance of Payment (as % of service exports) in 2008 in Georgia to that in Greece?
Give a very brief answer. 0.87. What is the ratio of the Balance of Payment (as % of service exports) of 2005 in Georgia to that in Guatemala?
Make the answer very short. 3.82. What is the ratio of the Balance of Payment (as % of service exports) of 2006 in Georgia to that in Guatemala?
Provide a succinct answer. 4.01. What is the ratio of the Balance of Payment (as % of service exports) of 2007 in Georgia to that in Guatemala?
Ensure brevity in your answer.  4.19. What is the ratio of the Balance of Payment (as % of service exports) of 2008 in Georgia to that in Guatemala?
Provide a succinct answer. 4.01. What is the ratio of the Balance of Payment (as % of service exports) in 2005 in Germany to that in Greece?
Make the answer very short. 0.46. What is the ratio of the Balance of Payment (as % of service exports) of 2006 in Germany to that in Greece?
Your response must be concise. 0.46. What is the ratio of the Balance of Payment (as % of service exports) of 2007 in Germany to that in Greece?
Your answer should be compact. 0.44. What is the ratio of the Balance of Payment (as % of service exports) in 2008 in Germany to that in Greece?
Make the answer very short. 0.45. What is the ratio of the Balance of Payment (as % of service exports) in 2005 in Germany to that in Guatemala?
Your answer should be very brief. 1.98. What is the ratio of the Balance of Payment (as % of service exports) of 2006 in Germany to that in Guatemala?
Ensure brevity in your answer.  2.06. What is the ratio of the Balance of Payment (as % of service exports) in 2007 in Germany to that in Guatemala?
Make the answer very short. 2.17. What is the ratio of the Balance of Payment (as % of service exports) in 2008 in Germany to that in Guatemala?
Your answer should be compact. 2.1. What is the ratio of the Balance of Payment (as % of service exports) of 2005 in Greece to that in Guatemala?
Your answer should be very brief. 4.31. What is the ratio of the Balance of Payment (as % of service exports) of 2006 in Greece to that in Guatemala?
Offer a terse response. 4.47. What is the ratio of the Balance of Payment (as % of service exports) in 2007 in Greece to that in Guatemala?
Make the answer very short. 4.88. What is the ratio of the Balance of Payment (as % of service exports) of 2008 in Greece to that in Guatemala?
Your response must be concise. 4.63. What is the difference between the highest and the second highest Balance of Payment (as % of service exports) in 2005?
Make the answer very short. 5.78. What is the difference between the highest and the second highest Balance of Payment (as % of service exports) of 2006?
Provide a succinct answer. 5.14. What is the difference between the highest and the second highest Balance of Payment (as % of service exports) in 2007?
Provide a succinct answer. 7.63. What is the difference between the highest and the second highest Balance of Payment (as % of service exports) in 2008?
Ensure brevity in your answer.  7.45. What is the difference between the highest and the lowest Balance of Payment (as % of service exports) of 2005?
Provide a succinct answer. 39.1. What is the difference between the highest and the lowest Balance of Payment (as % of service exports) of 2006?
Give a very brief answer. 39.02. What is the difference between the highest and the lowest Balance of Payment (as % of service exports) of 2007?
Provide a short and direct response. 42.9. What is the difference between the highest and the lowest Balance of Payment (as % of service exports) in 2008?
Give a very brief answer. 43.81. 